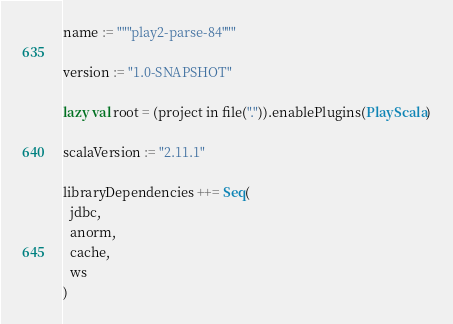<code> <loc_0><loc_0><loc_500><loc_500><_Scala_>name := """play2-parse-84"""

version := "1.0-SNAPSHOT"

lazy val root = (project in file(".")).enablePlugins(PlayScala)

scalaVersion := "2.11.1"

libraryDependencies ++= Seq(
  jdbc,
  anorm,
  cache,
  ws
)
</code> 